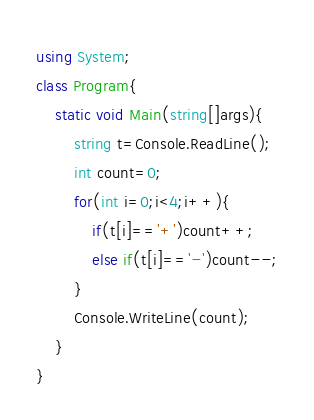<code> <loc_0><loc_0><loc_500><loc_500><_C#_>using System;
class Program{
    static void Main(string[]args){
        string t=Console.ReadLine();
        int count=0;
        for(int i=0;i<4;i++){
            if(t[i]=='+')count++;
            else if(t[i]=='-')count--;
        }
        Console.WriteLine(count);
    }
}</code> 